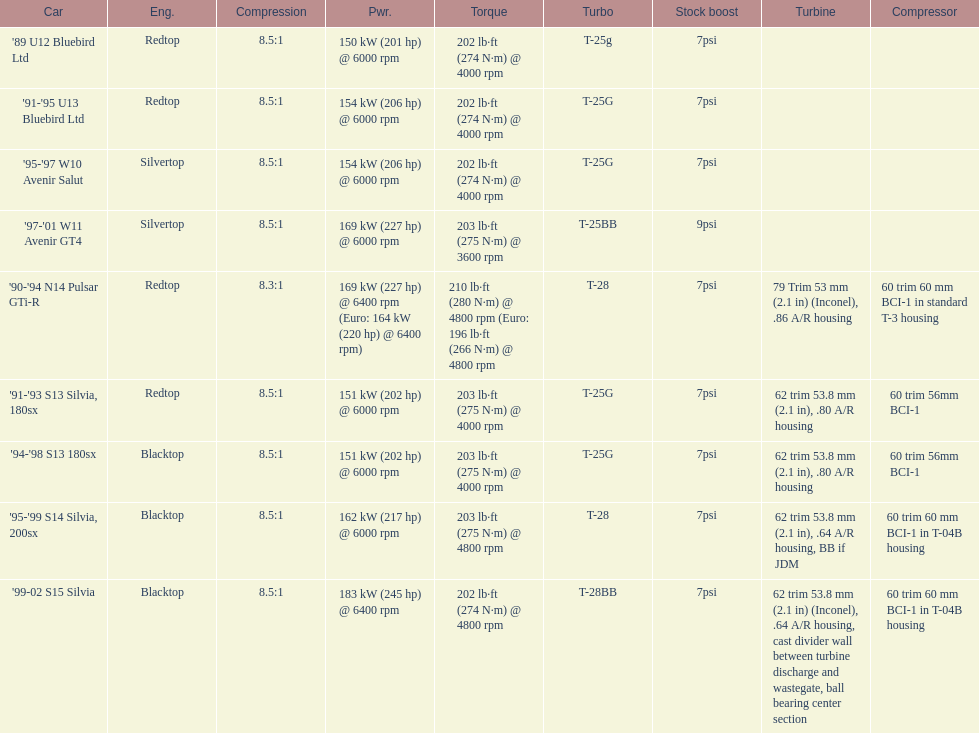Which car's power measured at higher than 6000 rpm? '90-'94 N14 Pulsar GTi-R, '99-02 S15 Silvia. 